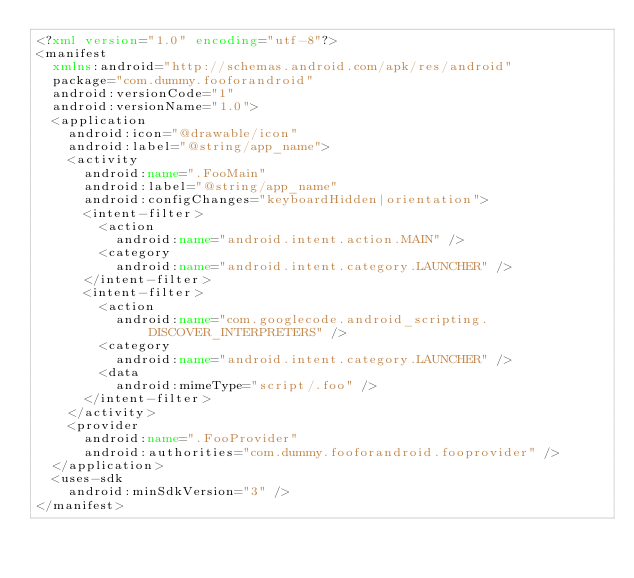<code> <loc_0><loc_0><loc_500><loc_500><_XML_><?xml version="1.0" encoding="utf-8"?>
<manifest
  xmlns:android="http://schemas.android.com/apk/res/android"
  package="com.dummy.fooforandroid"
  android:versionCode="1"
  android:versionName="1.0">
  <application
    android:icon="@drawable/icon"
    android:label="@string/app_name">
    <activity
      android:name=".FooMain"
      android:label="@string/app_name"
      android:configChanges="keyboardHidden|orientation">
      <intent-filter>
        <action
          android:name="android.intent.action.MAIN" />
        <category
          android:name="android.intent.category.LAUNCHER" />
      </intent-filter>
      <intent-filter>
        <action
          android:name="com.googlecode.android_scripting.DISCOVER_INTERPRETERS" />
        <category
          android:name="android.intent.category.LAUNCHER" />
        <data
          android:mimeType="script/.foo" />
      </intent-filter>
    </activity>
    <provider
      android:name=".FooProvider"
      android:authorities="com.dummy.fooforandroid.fooprovider" />
  </application>
  <uses-sdk
    android:minSdkVersion="3" />
</manifest></code> 